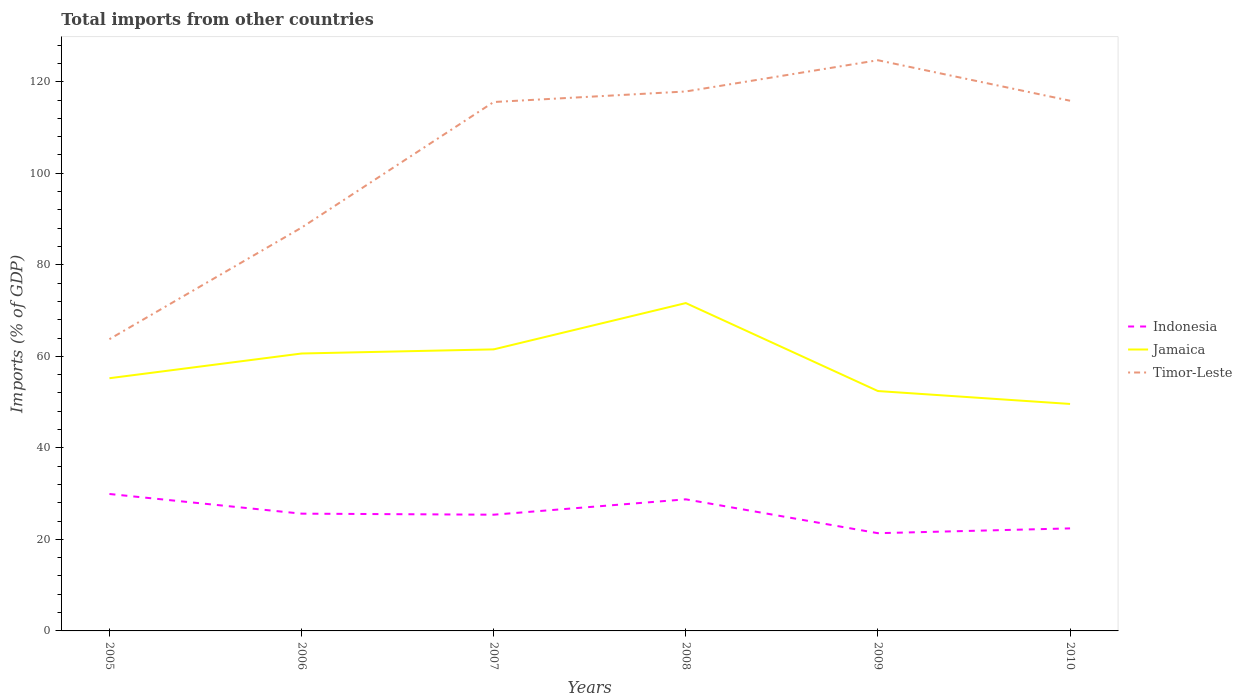How many different coloured lines are there?
Make the answer very short. 3. Does the line corresponding to Indonesia intersect with the line corresponding to Timor-Leste?
Ensure brevity in your answer.  No. Is the number of lines equal to the number of legend labels?
Ensure brevity in your answer.  Yes. Across all years, what is the maximum total imports in Timor-Leste?
Offer a terse response. 63.75. What is the total total imports in Timor-Leste in the graph?
Ensure brevity in your answer.  -0.28. What is the difference between the highest and the second highest total imports in Timor-Leste?
Offer a very short reply. 60.95. How many lines are there?
Keep it short and to the point. 3. How many years are there in the graph?
Offer a terse response. 6. What is the difference between two consecutive major ticks on the Y-axis?
Keep it short and to the point. 20. Are the values on the major ticks of Y-axis written in scientific E-notation?
Provide a succinct answer. No. Does the graph contain grids?
Offer a very short reply. No. Where does the legend appear in the graph?
Provide a succinct answer. Center right. How many legend labels are there?
Your answer should be very brief. 3. How are the legend labels stacked?
Provide a succinct answer. Vertical. What is the title of the graph?
Your response must be concise. Total imports from other countries. Does "Korea (Democratic)" appear as one of the legend labels in the graph?
Provide a succinct answer. No. What is the label or title of the Y-axis?
Ensure brevity in your answer.  Imports (% of GDP). What is the Imports (% of GDP) of Indonesia in 2005?
Ensure brevity in your answer.  29.92. What is the Imports (% of GDP) in Jamaica in 2005?
Give a very brief answer. 55.21. What is the Imports (% of GDP) in Timor-Leste in 2005?
Ensure brevity in your answer.  63.75. What is the Imports (% of GDP) in Indonesia in 2006?
Your response must be concise. 25.62. What is the Imports (% of GDP) of Jamaica in 2006?
Your answer should be very brief. 60.61. What is the Imports (% of GDP) of Timor-Leste in 2006?
Provide a short and direct response. 88.12. What is the Imports (% of GDP) of Indonesia in 2007?
Make the answer very short. 25.39. What is the Imports (% of GDP) of Jamaica in 2007?
Keep it short and to the point. 61.52. What is the Imports (% of GDP) in Timor-Leste in 2007?
Your response must be concise. 115.56. What is the Imports (% of GDP) in Indonesia in 2008?
Provide a succinct answer. 28.75. What is the Imports (% of GDP) of Jamaica in 2008?
Offer a very short reply. 71.63. What is the Imports (% of GDP) of Timor-Leste in 2008?
Give a very brief answer. 117.87. What is the Imports (% of GDP) of Indonesia in 2009?
Ensure brevity in your answer.  21.35. What is the Imports (% of GDP) in Jamaica in 2009?
Offer a terse response. 52.41. What is the Imports (% of GDP) in Timor-Leste in 2009?
Your response must be concise. 124.69. What is the Imports (% of GDP) in Indonesia in 2010?
Keep it short and to the point. 22.4. What is the Imports (% of GDP) in Jamaica in 2010?
Offer a very short reply. 49.59. What is the Imports (% of GDP) of Timor-Leste in 2010?
Offer a terse response. 115.85. Across all years, what is the maximum Imports (% of GDP) in Indonesia?
Make the answer very short. 29.92. Across all years, what is the maximum Imports (% of GDP) of Jamaica?
Give a very brief answer. 71.63. Across all years, what is the maximum Imports (% of GDP) of Timor-Leste?
Your response must be concise. 124.69. Across all years, what is the minimum Imports (% of GDP) of Indonesia?
Offer a terse response. 21.35. Across all years, what is the minimum Imports (% of GDP) in Jamaica?
Provide a succinct answer. 49.59. Across all years, what is the minimum Imports (% of GDP) of Timor-Leste?
Ensure brevity in your answer.  63.75. What is the total Imports (% of GDP) of Indonesia in the graph?
Provide a short and direct response. 153.44. What is the total Imports (% of GDP) of Jamaica in the graph?
Your response must be concise. 350.98. What is the total Imports (% of GDP) in Timor-Leste in the graph?
Offer a terse response. 625.84. What is the difference between the Imports (% of GDP) of Indonesia in 2005 and that in 2006?
Give a very brief answer. 4.3. What is the difference between the Imports (% of GDP) of Jamaica in 2005 and that in 2006?
Your answer should be compact. -5.4. What is the difference between the Imports (% of GDP) of Timor-Leste in 2005 and that in 2006?
Make the answer very short. -24.37. What is the difference between the Imports (% of GDP) in Indonesia in 2005 and that in 2007?
Provide a short and direct response. 4.53. What is the difference between the Imports (% of GDP) of Jamaica in 2005 and that in 2007?
Give a very brief answer. -6.3. What is the difference between the Imports (% of GDP) of Timor-Leste in 2005 and that in 2007?
Provide a short and direct response. -51.82. What is the difference between the Imports (% of GDP) of Indonesia in 2005 and that in 2008?
Provide a short and direct response. 1.17. What is the difference between the Imports (% of GDP) in Jamaica in 2005 and that in 2008?
Your response must be concise. -16.42. What is the difference between the Imports (% of GDP) in Timor-Leste in 2005 and that in 2008?
Your answer should be compact. -54.12. What is the difference between the Imports (% of GDP) of Indonesia in 2005 and that in 2009?
Your response must be concise. 8.57. What is the difference between the Imports (% of GDP) in Jamaica in 2005 and that in 2009?
Offer a very short reply. 2.8. What is the difference between the Imports (% of GDP) of Timor-Leste in 2005 and that in 2009?
Keep it short and to the point. -60.95. What is the difference between the Imports (% of GDP) of Indonesia in 2005 and that in 2010?
Ensure brevity in your answer.  7.52. What is the difference between the Imports (% of GDP) in Jamaica in 2005 and that in 2010?
Your response must be concise. 5.62. What is the difference between the Imports (% of GDP) in Timor-Leste in 2005 and that in 2010?
Give a very brief answer. -52.1. What is the difference between the Imports (% of GDP) in Indonesia in 2006 and that in 2007?
Provide a succinct answer. 0.23. What is the difference between the Imports (% of GDP) of Jamaica in 2006 and that in 2007?
Keep it short and to the point. -0.9. What is the difference between the Imports (% of GDP) in Timor-Leste in 2006 and that in 2007?
Your response must be concise. -27.44. What is the difference between the Imports (% of GDP) of Indonesia in 2006 and that in 2008?
Give a very brief answer. -3.13. What is the difference between the Imports (% of GDP) of Jamaica in 2006 and that in 2008?
Your response must be concise. -11.02. What is the difference between the Imports (% of GDP) in Timor-Leste in 2006 and that in 2008?
Your answer should be very brief. -29.75. What is the difference between the Imports (% of GDP) in Indonesia in 2006 and that in 2009?
Keep it short and to the point. 4.27. What is the difference between the Imports (% of GDP) of Jamaica in 2006 and that in 2009?
Provide a succinct answer. 8.2. What is the difference between the Imports (% of GDP) of Timor-Leste in 2006 and that in 2009?
Offer a very short reply. -36.57. What is the difference between the Imports (% of GDP) of Indonesia in 2006 and that in 2010?
Your answer should be very brief. 3.22. What is the difference between the Imports (% of GDP) in Jamaica in 2006 and that in 2010?
Provide a succinct answer. 11.02. What is the difference between the Imports (% of GDP) of Timor-Leste in 2006 and that in 2010?
Provide a short and direct response. -27.72. What is the difference between the Imports (% of GDP) of Indonesia in 2007 and that in 2008?
Make the answer very short. -3.36. What is the difference between the Imports (% of GDP) of Jamaica in 2007 and that in 2008?
Provide a short and direct response. -10.12. What is the difference between the Imports (% of GDP) of Timor-Leste in 2007 and that in 2008?
Your response must be concise. -2.3. What is the difference between the Imports (% of GDP) in Indonesia in 2007 and that in 2009?
Offer a terse response. 4.04. What is the difference between the Imports (% of GDP) in Jamaica in 2007 and that in 2009?
Your response must be concise. 9.1. What is the difference between the Imports (% of GDP) of Timor-Leste in 2007 and that in 2009?
Your answer should be compact. -9.13. What is the difference between the Imports (% of GDP) of Indonesia in 2007 and that in 2010?
Give a very brief answer. 2.99. What is the difference between the Imports (% of GDP) of Jamaica in 2007 and that in 2010?
Provide a short and direct response. 11.92. What is the difference between the Imports (% of GDP) in Timor-Leste in 2007 and that in 2010?
Your response must be concise. -0.28. What is the difference between the Imports (% of GDP) in Indonesia in 2008 and that in 2009?
Provide a short and direct response. 7.4. What is the difference between the Imports (% of GDP) of Jamaica in 2008 and that in 2009?
Offer a very short reply. 19.22. What is the difference between the Imports (% of GDP) of Timor-Leste in 2008 and that in 2009?
Your answer should be compact. -6.83. What is the difference between the Imports (% of GDP) in Indonesia in 2008 and that in 2010?
Offer a terse response. 6.35. What is the difference between the Imports (% of GDP) of Jamaica in 2008 and that in 2010?
Make the answer very short. 22.04. What is the difference between the Imports (% of GDP) in Timor-Leste in 2008 and that in 2010?
Ensure brevity in your answer.  2.02. What is the difference between the Imports (% of GDP) of Indonesia in 2009 and that in 2010?
Your answer should be very brief. -1.05. What is the difference between the Imports (% of GDP) of Jamaica in 2009 and that in 2010?
Your answer should be very brief. 2.82. What is the difference between the Imports (% of GDP) of Timor-Leste in 2009 and that in 2010?
Ensure brevity in your answer.  8.85. What is the difference between the Imports (% of GDP) of Indonesia in 2005 and the Imports (% of GDP) of Jamaica in 2006?
Keep it short and to the point. -30.69. What is the difference between the Imports (% of GDP) in Indonesia in 2005 and the Imports (% of GDP) in Timor-Leste in 2006?
Give a very brief answer. -58.2. What is the difference between the Imports (% of GDP) in Jamaica in 2005 and the Imports (% of GDP) in Timor-Leste in 2006?
Ensure brevity in your answer.  -32.91. What is the difference between the Imports (% of GDP) in Indonesia in 2005 and the Imports (% of GDP) in Jamaica in 2007?
Provide a short and direct response. -31.6. What is the difference between the Imports (% of GDP) of Indonesia in 2005 and the Imports (% of GDP) of Timor-Leste in 2007?
Your answer should be very brief. -85.64. What is the difference between the Imports (% of GDP) of Jamaica in 2005 and the Imports (% of GDP) of Timor-Leste in 2007?
Offer a terse response. -60.35. What is the difference between the Imports (% of GDP) in Indonesia in 2005 and the Imports (% of GDP) in Jamaica in 2008?
Give a very brief answer. -41.71. What is the difference between the Imports (% of GDP) of Indonesia in 2005 and the Imports (% of GDP) of Timor-Leste in 2008?
Offer a terse response. -87.95. What is the difference between the Imports (% of GDP) of Jamaica in 2005 and the Imports (% of GDP) of Timor-Leste in 2008?
Your response must be concise. -62.65. What is the difference between the Imports (% of GDP) in Indonesia in 2005 and the Imports (% of GDP) in Jamaica in 2009?
Offer a terse response. -22.49. What is the difference between the Imports (% of GDP) of Indonesia in 2005 and the Imports (% of GDP) of Timor-Leste in 2009?
Offer a very short reply. -94.77. What is the difference between the Imports (% of GDP) of Jamaica in 2005 and the Imports (% of GDP) of Timor-Leste in 2009?
Give a very brief answer. -69.48. What is the difference between the Imports (% of GDP) in Indonesia in 2005 and the Imports (% of GDP) in Jamaica in 2010?
Give a very brief answer. -19.67. What is the difference between the Imports (% of GDP) in Indonesia in 2005 and the Imports (% of GDP) in Timor-Leste in 2010?
Your answer should be compact. -85.93. What is the difference between the Imports (% of GDP) of Jamaica in 2005 and the Imports (% of GDP) of Timor-Leste in 2010?
Ensure brevity in your answer.  -60.63. What is the difference between the Imports (% of GDP) in Indonesia in 2006 and the Imports (% of GDP) in Jamaica in 2007?
Provide a succinct answer. -35.89. What is the difference between the Imports (% of GDP) of Indonesia in 2006 and the Imports (% of GDP) of Timor-Leste in 2007?
Your response must be concise. -89.94. What is the difference between the Imports (% of GDP) of Jamaica in 2006 and the Imports (% of GDP) of Timor-Leste in 2007?
Offer a terse response. -54.95. What is the difference between the Imports (% of GDP) in Indonesia in 2006 and the Imports (% of GDP) in Jamaica in 2008?
Offer a very short reply. -46.01. What is the difference between the Imports (% of GDP) in Indonesia in 2006 and the Imports (% of GDP) in Timor-Leste in 2008?
Your response must be concise. -92.25. What is the difference between the Imports (% of GDP) of Jamaica in 2006 and the Imports (% of GDP) of Timor-Leste in 2008?
Give a very brief answer. -57.25. What is the difference between the Imports (% of GDP) of Indonesia in 2006 and the Imports (% of GDP) of Jamaica in 2009?
Give a very brief answer. -26.79. What is the difference between the Imports (% of GDP) of Indonesia in 2006 and the Imports (% of GDP) of Timor-Leste in 2009?
Your answer should be compact. -99.07. What is the difference between the Imports (% of GDP) in Jamaica in 2006 and the Imports (% of GDP) in Timor-Leste in 2009?
Ensure brevity in your answer.  -64.08. What is the difference between the Imports (% of GDP) of Indonesia in 2006 and the Imports (% of GDP) of Jamaica in 2010?
Offer a very short reply. -23.97. What is the difference between the Imports (% of GDP) of Indonesia in 2006 and the Imports (% of GDP) of Timor-Leste in 2010?
Offer a very short reply. -90.22. What is the difference between the Imports (% of GDP) of Jamaica in 2006 and the Imports (% of GDP) of Timor-Leste in 2010?
Provide a succinct answer. -55.23. What is the difference between the Imports (% of GDP) in Indonesia in 2007 and the Imports (% of GDP) in Jamaica in 2008?
Offer a very short reply. -46.24. What is the difference between the Imports (% of GDP) of Indonesia in 2007 and the Imports (% of GDP) of Timor-Leste in 2008?
Keep it short and to the point. -92.47. What is the difference between the Imports (% of GDP) in Jamaica in 2007 and the Imports (% of GDP) in Timor-Leste in 2008?
Give a very brief answer. -56.35. What is the difference between the Imports (% of GDP) of Indonesia in 2007 and the Imports (% of GDP) of Jamaica in 2009?
Keep it short and to the point. -27.02. What is the difference between the Imports (% of GDP) in Indonesia in 2007 and the Imports (% of GDP) in Timor-Leste in 2009?
Ensure brevity in your answer.  -99.3. What is the difference between the Imports (% of GDP) of Jamaica in 2007 and the Imports (% of GDP) of Timor-Leste in 2009?
Your response must be concise. -63.18. What is the difference between the Imports (% of GDP) in Indonesia in 2007 and the Imports (% of GDP) in Jamaica in 2010?
Ensure brevity in your answer.  -24.2. What is the difference between the Imports (% of GDP) in Indonesia in 2007 and the Imports (% of GDP) in Timor-Leste in 2010?
Your response must be concise. -90.45. What is the difference between the Imports (% of GDP) in Jamaica in 2007 and the Imports (% of GDP) in Timor-Leste in 2010?
Your answer should be very brief. -54.33. What is the difference between the Imports (% of GDP) in Indonesia in 2008 and the Imports (% of GDP) in Jamaica in 2009?
Give a very brief answer. -23.66. What is the difference between the Imports (% of GDP) in Indonesia in 2008 and the Imports (% of GDP) in Timor-Leste in 2009?
Your response must be concise. -95.94. What is the difference between the Imports (% of GDP) in Jamaica in 2008 and the Imports (% of GDP) in Timor-Leste in 2009?
Provide a succinct answer. -53.06. What is the difference between the Imports (% of GDP) of Indonesia in 2008 and the Imports (% of GDP) of Jamaica in 2010?
Ensure brevity in your answer.  -20.84. What is the difference between the Imports (% of GDP) in Indonesia in 2008 and the Imports (% of GDP) in Timor-Leste in 2010?
Give a very brief answer. -87.09. What is the difference between the Imports (% of GDP) of Jamaica in 2008 and the Imports (% of GDP) of Timor-Leste in 2010?
Give a very brief answer. -44.21. What is the difference between the Imports (% of GDP) of Indonesia in 2009 and the Imports (% of GDP) of Jamaica in 2010?
Make the answer very short. -28.24. What is the difference between the Imports (% of GDP) of Indonesia in 2009 and the Imports (% of GDP) of Timor-Leste in 2010?
Make the answer very short. -94.49. What is the difference between the Imports (% of GDP) of Jamaica in 2009 and the Imports (% of GDP) of Timor-Leste in 2010?
Offer a terse response. -63.43. What is the average Imports (% of GDP) of Indonesia per year?
Provide a succinct answer. 25.57. What is the average Imports (% of GDP) in Jamaica per year?
Make the answer very short. 58.5. What is the average Imports (% of GDP) in Timor-Leste per year?
Provide a short and direct response. 104.31. In the year 2005, what is the difference between the Imports (% of GDP) in Indonesia and Imports (% of GDP) in Jamaica?
Your answer should be compact. -25.29. In the year 2005, what is the difference between the Imports (% of GDP) of Indonesia and Imports (% of GDP) of Timor-Leste?
Your response must be concise. -33.83. In the year 2005, what is the difference between the Imports (% of GDP) of Jamaica and Imports (% of GDP) of Timor-Leste?
Provide a succinct answer. -8.53. In the year 2006, what is the difference between the Imports (% of GDP) of Indonesia and Imports (% of GDP) of Jamaica?
Your answer should be compact. -34.99. In the year 2006, what is the difference between the Imports (% of GDP) of Indonesia and Imports (% of GDP) of Timor-Leste?
Ensure brevity in your answer.  -62.5. In the year 2006, what is the difference between the Imports (% of GDP) of Jamaica and Imports (% of GDP) of Timor-Leste?
Ensure brevity in your answer.  -27.51. In the year 2007, what is the difference between the Imports (% of GDP) of Indonesia and Imports (% of GDP) of Jamaica?
Offer a very short reply. -36.12. In the year 2007, what is the difference between the Imports (% of GDP) of Indonesia and Imports (% of GDP) of Timor-Leste?
Offer a very short reply. -90.17. In the year 2007, what is the difference between the Imports (% of GDP) in Jamaica and Imports (% of GDP) in Timor-Leste?
Your response must be concise. -54.05. In the year 2008, what is the difference between the Imports (% of GDP) in Indonesia and Imports (% of GDP) in Jamaica?
Make the answer very short. -42.88. In the year 2008, what is the difference between the Imports (% of GDP) of Indonesia and Imports (% of GDP) of Timor-Leste?
Provide a succinct answer. -89.11. In the year 2008, what is the difference between the Imports (% of GDP) of Jamaica and Imports (% of GDP) of Timor-Leste?
Your response must be concise. -46.23. In the year 2009, what is the difference between the Imports (% of GDP) in Indonesia and Imports (% of GDP) in Jamaica?
Your response must be concise. -31.06. In the year 2009, what is the difference between the Imports (% of GDP) of Indonesia and Imports (% of GDP) of Timor-Leste?
Ensure brevity in your answer.  -103.34. In the year 2009, what is the difference between the Imports (% of GDP) in Jamaica and Imports (% of GDP) in Timor-Leste?
Give a very brief answer. -72.28. In the year 2010, what is the difference between the Imports (% of GDP) of Indonesia and Imports (% of GDP) of Jamaica?
Offer a very short reply. -27.19. In the year 2010, what is the difference between the Imports (% of GDP) in Indonesia and Imports (% of GDP) in Timor-Leste?
Provide a short and direct response. -93.44. In the year 2010, what is the difference between the Imports (% of GDP) of Jamaica and Imports (% of GDP) of Timor-Leste?
Offer a very short reply. -66.25. What is the ratio of the Imports (% of GDP) of Indonesia in 2005 to that in 2006?
Your answer should be very brief. 1.17. What is the ratio of the Imports (% of GDP) in Jamaica in 2005 to that in 2006?
Your answer should be compact. 0.91. What is the ratio of the Imports (% of GDP) in Timor-Leste in 2005 to that in 2006?
Your answer should be very brief. 0.72. What is the ratio of the Imports (% of GDP) in Indonesia in 2005 to that in 2007?
Offer a very short reply. 1.18. What is the ratio of the Imports (% of GDP) of Jamaica in 2005 to that in 2007?
Give a very brief answer. 0.9. What is the ratio of the Imports (% of GDP) of Timor-Leste in 2005 to that in 2007?
Offer a very short reply. 0.55. What is the ratio of the Imports (% of GDP) of Indonesia in 2005 to that in 2008?
Your answer should be very brief. 1.04. What is the ratio of the Imports (% of GDP) of Jamaica in 2005 to that in 2008?
Keep it short and to the point. 0.77. What is the ratio of the Imports (% of GDP) of Timor-Leste in 2005 to that in 2008?
Your answer should be very brief. 0.54. What is the ratio of the Imports (% of GDP) of Indonesia in 2005 to that in 2009?
Offer a terse response. 1.4. What is the ratio of the Imports (% of GDP) of Jamaica in 2005 to that in 2009?
Your answer should be compact. 1.05. What is the ratio of the Imports (% of GDP) of Timor-Leste in 2005 to that in 2009?
Ensure brevity in your answer.  0.51. What is the ratio of the Imports (% of GDP) in Indonesia in 2005 to that in 2010?
Your answer should be compact. 1.34. What is the ratio of the Imports (% of GDP) of Jamaica in 2005 to that in 2010?
Provide a short and direct response. 1.11. What is the ratio of the Imports (% of GDP) of Timor-Leste in 2005 to that in 2010?
Your answer should be very brief. 0.55. What is the ratio of the Imports (% of GDP) in Timor-Leste in 2006 to that in 2007?
Your answer should be very brief. 0.76. What is the ratio of the Imports (% of GDP) of Indonesia in 2006 to that in 2008?
Give a very brief answer. 0.89. What is the ratio of the Imports (% of GDP) of Jamaica in 2006 to that in 2008?
Make the answer very short. 0.85. What is the ratio of the Imports (% of GDP) of Timor-Leste in 2006 to that in 2008?
Offer a terse response. 0.75. What is the ratio of the Imports (% of GDP) in Indonesia in 2006 to that in 2009?
Ensure brevity in your answer.  1.2. What is the ratio of the Imports (% of GDP) in Jamaica in 2006 to that in 2009?
Ensure brevity in your answer.  1.16. What is the ratio of the Imports (% of GDP) in Timor-Leste in 2006 to that in 2009?
Your answer should be very brief. 0.71. What is the ratio of the Imports (% of GDP) in Indonesia in 2006 to that in 2010?
Give a very brief answer. 1.14. What is the ratio of the Imports (% of GDP) of Jamaica in 2006 to that in 2010?
Ensure brevity in your answer.  1.22. What is the ratio of the Imports (% of GDP) in Timor-Leste in 2006 to that in 2010?
Ensure brevity in your answer.  0.76. What is the ratio of the Imports (% of GDP) in Indonesia in 2007 to that in 2008?
Offer a terse response. 0.88. What is the ratio of the Imports (% of GDP) in Jamaica in 2007 to that in 2008?
Keep it short and to the point. 0.86. What is the ratio of the Imports (% of GDP) in Timor-Leste in 2007 to that in 2008?
Make the answer very short. 0.98. What is the ratio of the Imports (% of GDP) in Indonesia in 2007 to that in 2009?
Provide a short and direct response. 1.19. What is the ratio of the Imports (% of GDP) of Jamaica in 2007 to that in 2009?
Your response must be concise. 1.17. What is the ratio of the Imports (% of GDP) in Timor-Leste in 2007 to that in 2009?
Ensure brevity in your answer.  0.93. What is the ratio of the Imports (% of GDP) of Indonesia in 2007 to that in 2010?
Provide a short and direct response. 1.13. What is the ratio of the Imports (% of GDP) in Jamaica in 2007 to that in 2010?
Your answer should be compact. 1.24. What is the ratio of the Imports (% of GDP) in Indonesia in 2008 to that in 2009?
Give a very brief answer. 1.35. What is the ratio of the Imports (% of GDP) in Jamaica in 2008 to that in 2009?
Give a very brief answer. 1.37. What is the ratio of the Imports (% of GDP) of Timor-Leste in 2008 to that in 2009?
Your answer should be compact. 0.95. What is the ratio of the Imports (% of GDP) in Indonesia in 2008 to that in 2010?
Offer a terse response. 1.28. What is the ratio of the Imports (% of GDP) of Jamaica in 2008 to that in 2010?
Your answer should be compact. 1.44. What is the ratio of the Imports (% of GDP) of Timor-Leste in 2008 to that in 2010?
Your response must be concise. 1.02. What is the ratio of the Imports (% of GDP) in Indonesia in 2009 to that in 2010?
Offer a terse response. 0.95. What is the ratio of the Imports (% of GDP) of Jamaica in 2009 to that in 2010?
Offer a terse response. 1.06. What is the ratio of the Imports (% of GDP) of Timor-Leste in 2009 to that in 2010?
Provide a succinct answer. 1.08. What is the difference between the highest and the second highest Imports (% of GDP) in Indonesia?
Your answer should be very brief. 1.17. What is the difference between the highest and the second highest Imports (% of GDP) of Jamaica?
Your answer should be compact. 10.12. What is the difference between the highest and the second highest Imports (% of GDP) of Timor-Leste?
Offer a very short reply. 6.83. What is the difference between the highest and the lowest Imports (% of GDP) in Indonesia?
Keep it short and to the point. 8.57. What is the difference between the highest and the lowest Imports (% of GDP) of Jamaica?
Make the answer very short. 22.04. What is the difference between the highest and the lowest Imports (% of GDP) in Timor-Leste?
Your answer should be very brief. 60.95. 